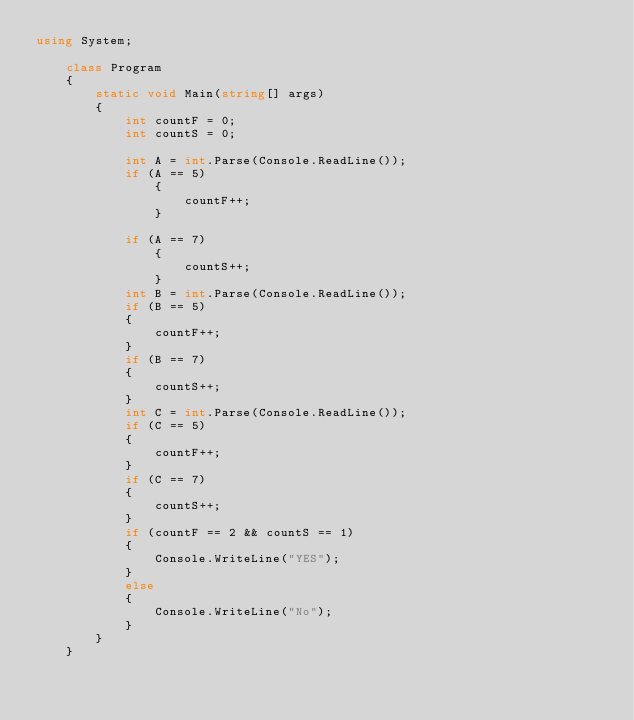<code> <loc_0><loc_0><loc_500><loc_500><_C#_>using System;

    class Program
    { 
        static void Main(string[] args)
        {
            int countF = 0;
            int countS = 0;

            int A = int.Parse(Console.ReadLine());
            if (A == 5)
                {
                    countF++;
                }

            if (A == 7)
                {
                    countS++;
                }
            int B = int.Parse(Console.ReadLine());
            if (B == 5)
            {
                countF++;
            }
            if (B == 7)
            {
                countS++;
            }
            int C = int.Parse(Console.ReadLine());
            if (C == 5)
            {
                countF++;
            }
            if (C == 7)
            {
                countS++;
            }
            if (countF == 2 && countS == 1)
            {
                Console.WriteLine("YES");
            }
            else 
            {
                Console.WriteLine("No");
            }
        }
    }
</code> 